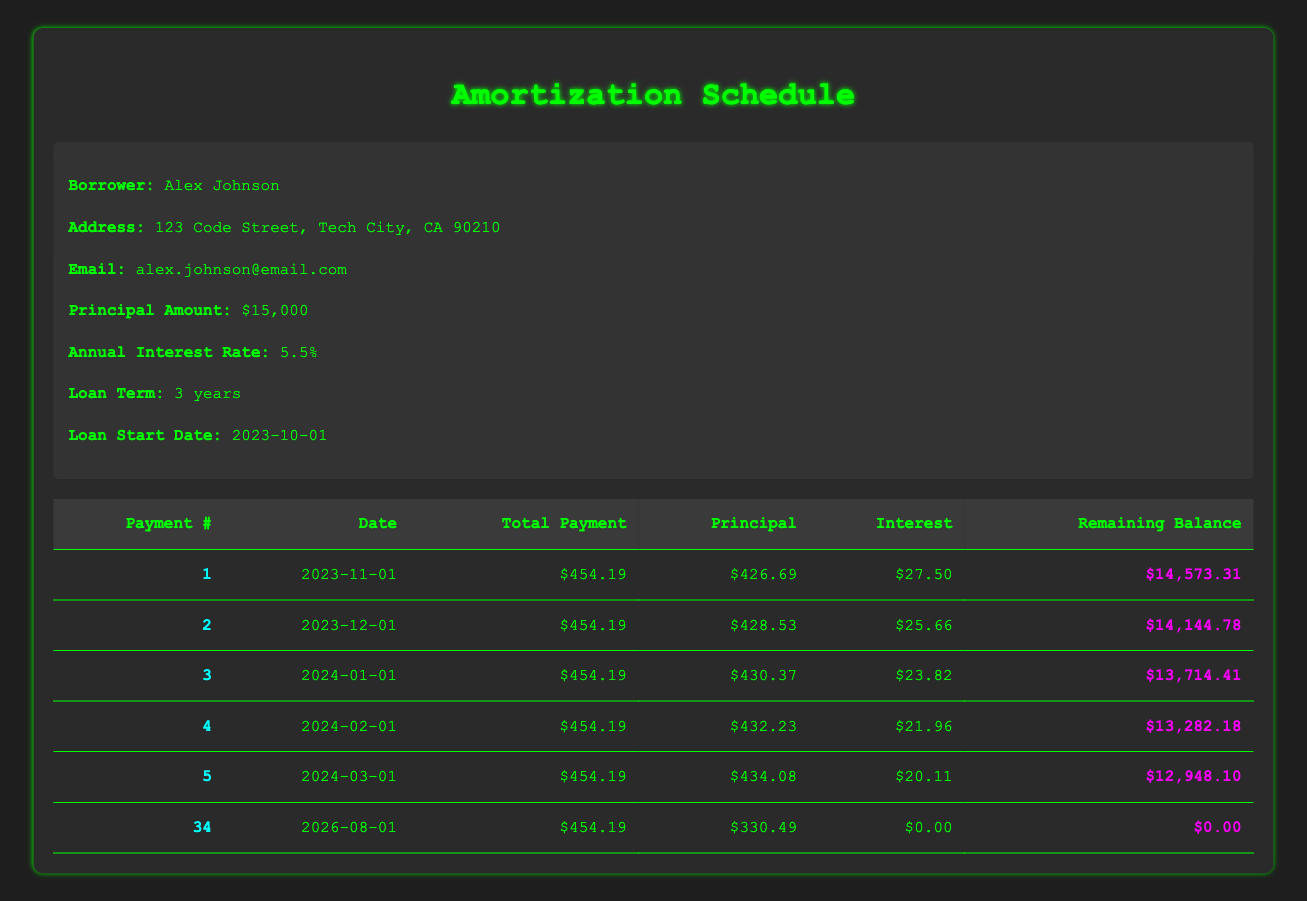What is the total principal payment made in the first three months? To calculate the total principal payment for the first three months, we add the principal payments from the first three rows of the schedule: 426.69 + 428.53 + 430.37 = 1285.59
Answer: 1285.59 What is the remaining balance after the 12th payment? The remaining balance after the 12th payment can be found directly in the table corresponding to payment number 12, which is $10,057.83.
Answer: 10057.83 Was the interest payment for the 17th month negative? The interest payment for the 17th month, according to the table, is -0.01, which confirms that it was indeed negative.
Answer: Yes What is the date of the final payment? The final payment is indicated by payment number 34, which is scheduled for 2026-08-01.
Answer: 2026-08-01 How much total payment is made on the 21st payment date? The total payment on the 21st payment date can be found in the table, where it shows a total payment of $454.19.
Answer: 454.19 What was the average interest payment over the first six months? To find the average interest payment, we total the interest payments for the first six months: 27.50 + 25.66 + 23.82 + 21.96 + 20.11 + 18.24 = 137.29. Then, we divide by the number of payments (6), giving us an average of 137.29 / 6 = 22.88.
Answer: 22.88 What is the principal payment amount for the 15th month? The principal payment amount for the 15th month is directly listed in the table as 453.01.
Answer: 453.01 Did the monthly total payment amount change at any point during the loan term? The total payment amount remains constant at $454.19 throughout the loan term, as verified in the table.
Answer: No What is the difference between the principal payment on the first and the last payment? The principal payment for the first payment is 426.69, and for the last payment (payment number 34), it is 330.49. The difference is calculated as 426.69 - 330.49 = 96.20.
Answer: 96.20 